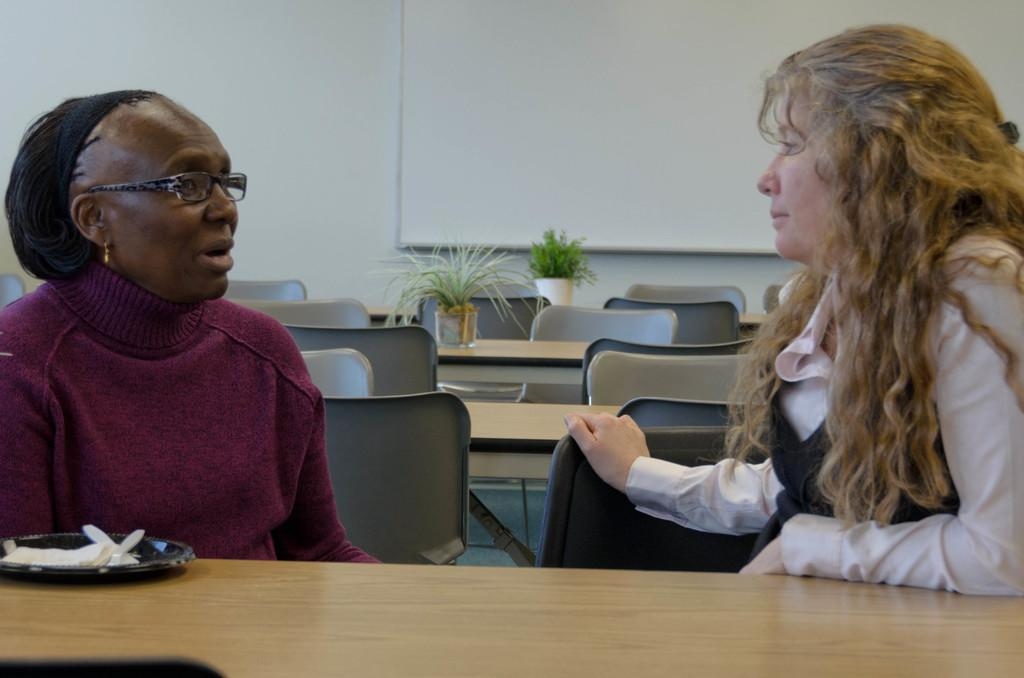How many people are in the image? There are two women in the image. What is one of the women doing in the image? One of the women is speaking. How is the other woman in the image reacting to the speaking woman? The other woman is looking at the one who is speaking. What type of flag is being waved during the feast in the image? There is no flag or feast present in the image; it features two women, one speaking and the other looking at her. Is the quicksand visible in the image? There is no quicksand present in the image. 